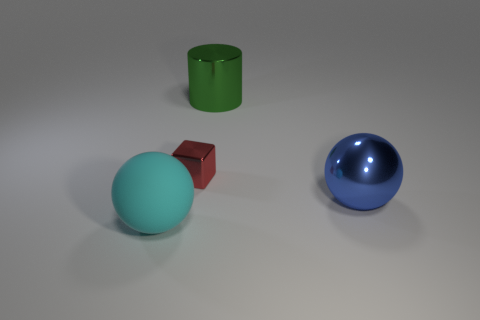How many things are either shiny things or blue rubber things?
Your response must be concise. 3. Is there a small gray metallic block?
Your answer should be compact. No. There is a thing in front of the sphere on the right side of the large shiny thing that is on the left side of the big blue metal ball; what is its material?
Offer a very short reply. Rubber. Are there fewer tiny cubes left of the block than big objects?
Keep it short and to the point. Yes. There is another sphere that is the same size as the cyan rubber sphere; what is it made of?
Provide a succinct answer. Metal. There is a object that is both left of the big green cylinder and in front of the shiny cube; what is its size?
Ensure brevity in your answer.  Large. The other object that is the same shape as the big blue thing is what size?
Give a very brief answer. Large. How many things are either big cyan shiny blocks or shiny objects in front of the green cylinder?
Provide a succinct answer. 2. The small red shiny thing is what shape?
Ensure brevity in your answer.  Cube. There is a big metallic thing behind the metallic object left of the large green metal cylinder; what shape is it?
Provide a succinct answer. Cylinder. 